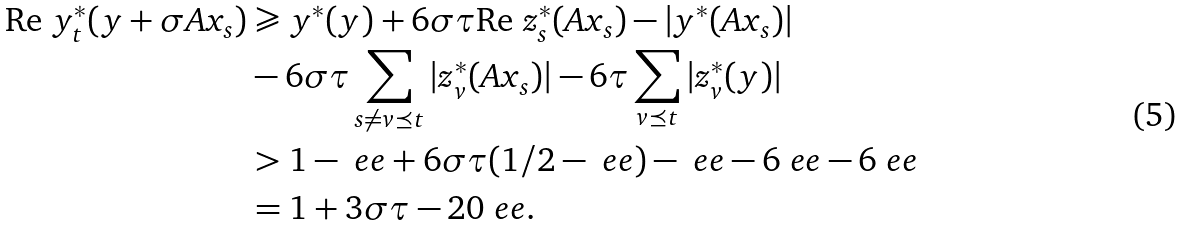<formula> <loc_0><loc_0><loc_500><loc_500>\text {Re\ } y ^ { * } _ { t } ( y + \sigma A x _ { s } ) & \geqslant y ^ { * } ( y ) + 6 \sigma \tau \text {Re\ } z ^ { * } _ { s } ( A x _ { s } ) - | y ^ { * } ( A x _ { s } ) | \\ & - 6 \sigma \tau \sum _ { s \neq v \preceq t } | z ^ { * } _ { v } ( A x _ { s } ) | - 6 \tau \sum _ { v \preceq t } | z ^ { * } _ { v } ( y ) | \\ & > 1 - \ e e + 6 \sigma \tau ( 1 / 2 - \ e e ) - \ e e - 6 \ e e - 6 \ e e \\ & = 1 + 3 \sigma \tau - 2 0 \ e e .</formula> 